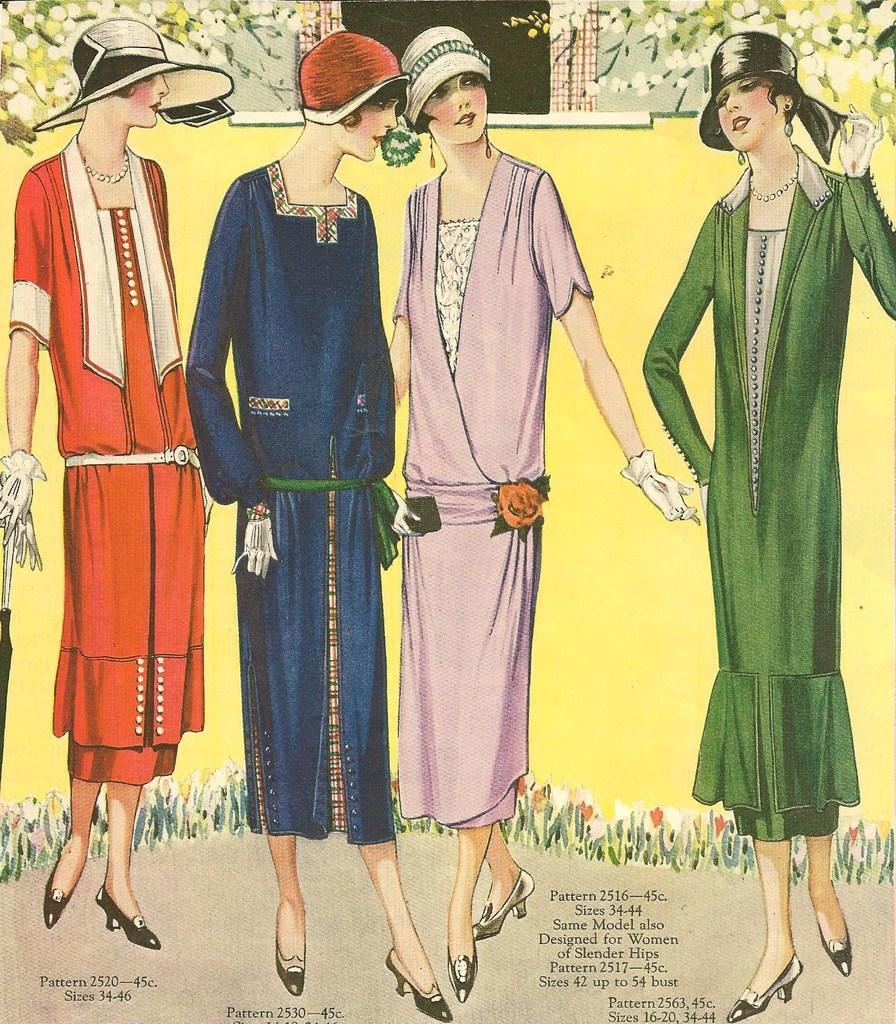Can you describe this image briefly? In this image there is a painting. In the painting there are four women standing, behind them there is a wall and flowers on the plants. At the bottom of the painting there is some text. 